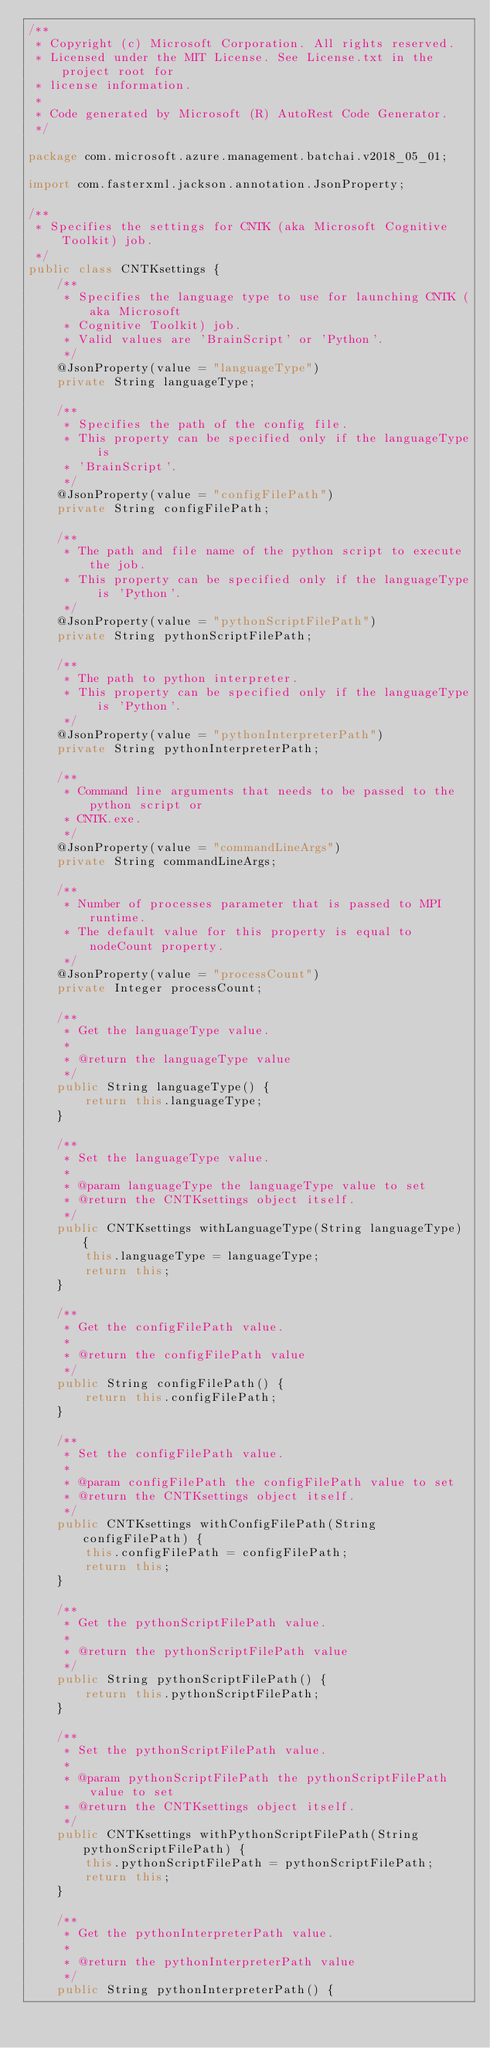<code> <loc_0><loc_0><loc_500><loc_500><_Java_>/**
 * Copyright (c) Microsoft Corporation. All rights reserved.
 * Licensed under the MIT License. See License.txt in the project root for
 * license information.
 *
 * Code generated by Microsoft (R) AutoRest Code Generator.
 */

package com.microsoft.azure.management.batchai.v2018_05_01;

import com.fasterxml.jackson.annotation.JsonProperty;

/**
 * Specifies the settings for CNTK (aka Microsoft Cognitive Toolkit) job.
 */
public class CNTKsettings {
    /**
     * Specifies the language type to use for launching CNTK (aka Microsoft
     * Cognitive Toolkit) job.
     * Valid values are 'BrainScript' or 'Python'.
     */
    @JsonProperty(value = "languageType")
    private String languageType;

    /**
     * Specifies the path of the config file.
     * This property can be specified only if the languageType is
     * 'BrainScript'.
     */
    @JsonProperty(value = "configFilePath")
    private String configFilePath;

    /**
     * The path and file name of the python script to execute the job.
     * This property can be specified only if the languageType is 'Python'.
     */
    @JsonProperty(value = "pythonScriptFilePath")
    private String pythonScriptFilePath;

    /**
     * The path to python interpreter.
     * This property can be specified only if the languageType is 'Python'.
     */
    @JsonProperty(value = "pythonInterpreterPath")
    private String pythonInterpreterPath;

    /**
     * Command line arguments that needs to be passed to the python script or
     * CNTK.exe.
     */
    @JsonProperty(value = "commandLineArgs")
    private String commandLineArgs;

    /**
     * Number of processes parameter that is passed to MPI runtime.
     * The default value for this property is equal to nodeCount property.
     */
    @JsonProperty(value = "processCount")
    private Integer processCount;

    /**
     * Get the languageType value.
     *
     * @return the languageType value
     */
    public String languageType() {
        return this.languageType;
    }

    /**
     * Set the languageType value.
     *
     * @param languageType the languageType value to set
     * @return the CNTKsettings object itself.
     */
    public CNTKsettings withLanguageType(String languageType) {
        this.languageType = languageType;
        return this;
    }

    /**
     * Get the configFilePath value.
     *
     * @return the configFilePath value
     */
    public String configFilePath() {
        return this.configFilePath;
    }

    /**
     * Set the configFilePath value.
     *
     * @param configFilePath the configFilePath value to set
     * @return the CNTKsettings object itself.
     */
    public CNTKsettings withConfigFilePath(String configFilePath) {
        this.configFilePath = configFilePath;
        return this;
    }

    /**
     * Get the pythonScriptFilePath value.
     *
     * @return the pythonScriptFilePath value
     */
    public String pythonScriptFilePath() {
        return this.pythonScriptFilePath;
    }

    /**
     * Set the pythonScriptFilePath value.
     *
     * @param pythonScriptFilePath the pythonScriptFilePath value to set
     * @return the CNTKsettings object itself.
     */
    public CNTKsettings withPythonScriptFilePath(String pythonScriptFilePath) {
        this.pythonScriptFilePath = pythonScriptFilePath;
        return this;
    }

    /**
     * Get the pythonInterpreterPath value.
     *
     * @return the pythonInterpreterPath value
     */
    public String pythonInterpreterPath() {</code> 